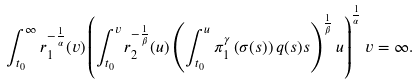<formula> <loc_0><loc_0><loc_500><loc_500>\int _ { t _ { 0 } } ^ { \infty } r _ { 1 } ^ { - \frac { 1 } { \alpha } } ( v ) \left ( \int _ { t _ { 0 } } ^ { v } r _ { 2 } ^ { - \frac { 1 } { \beta } } ( u ) \left ( \int _ { t _ { 0 } } ^ { u } \pi _ { 1 } ^ { \gamma } \left ( \sigma ( s ) \right ) q ( s ) s \right ) ^ { \frac { 1 } { \beta } } u \right ) ^ { \frac { 1 } { \alpha } } v = \infty .</formula> 